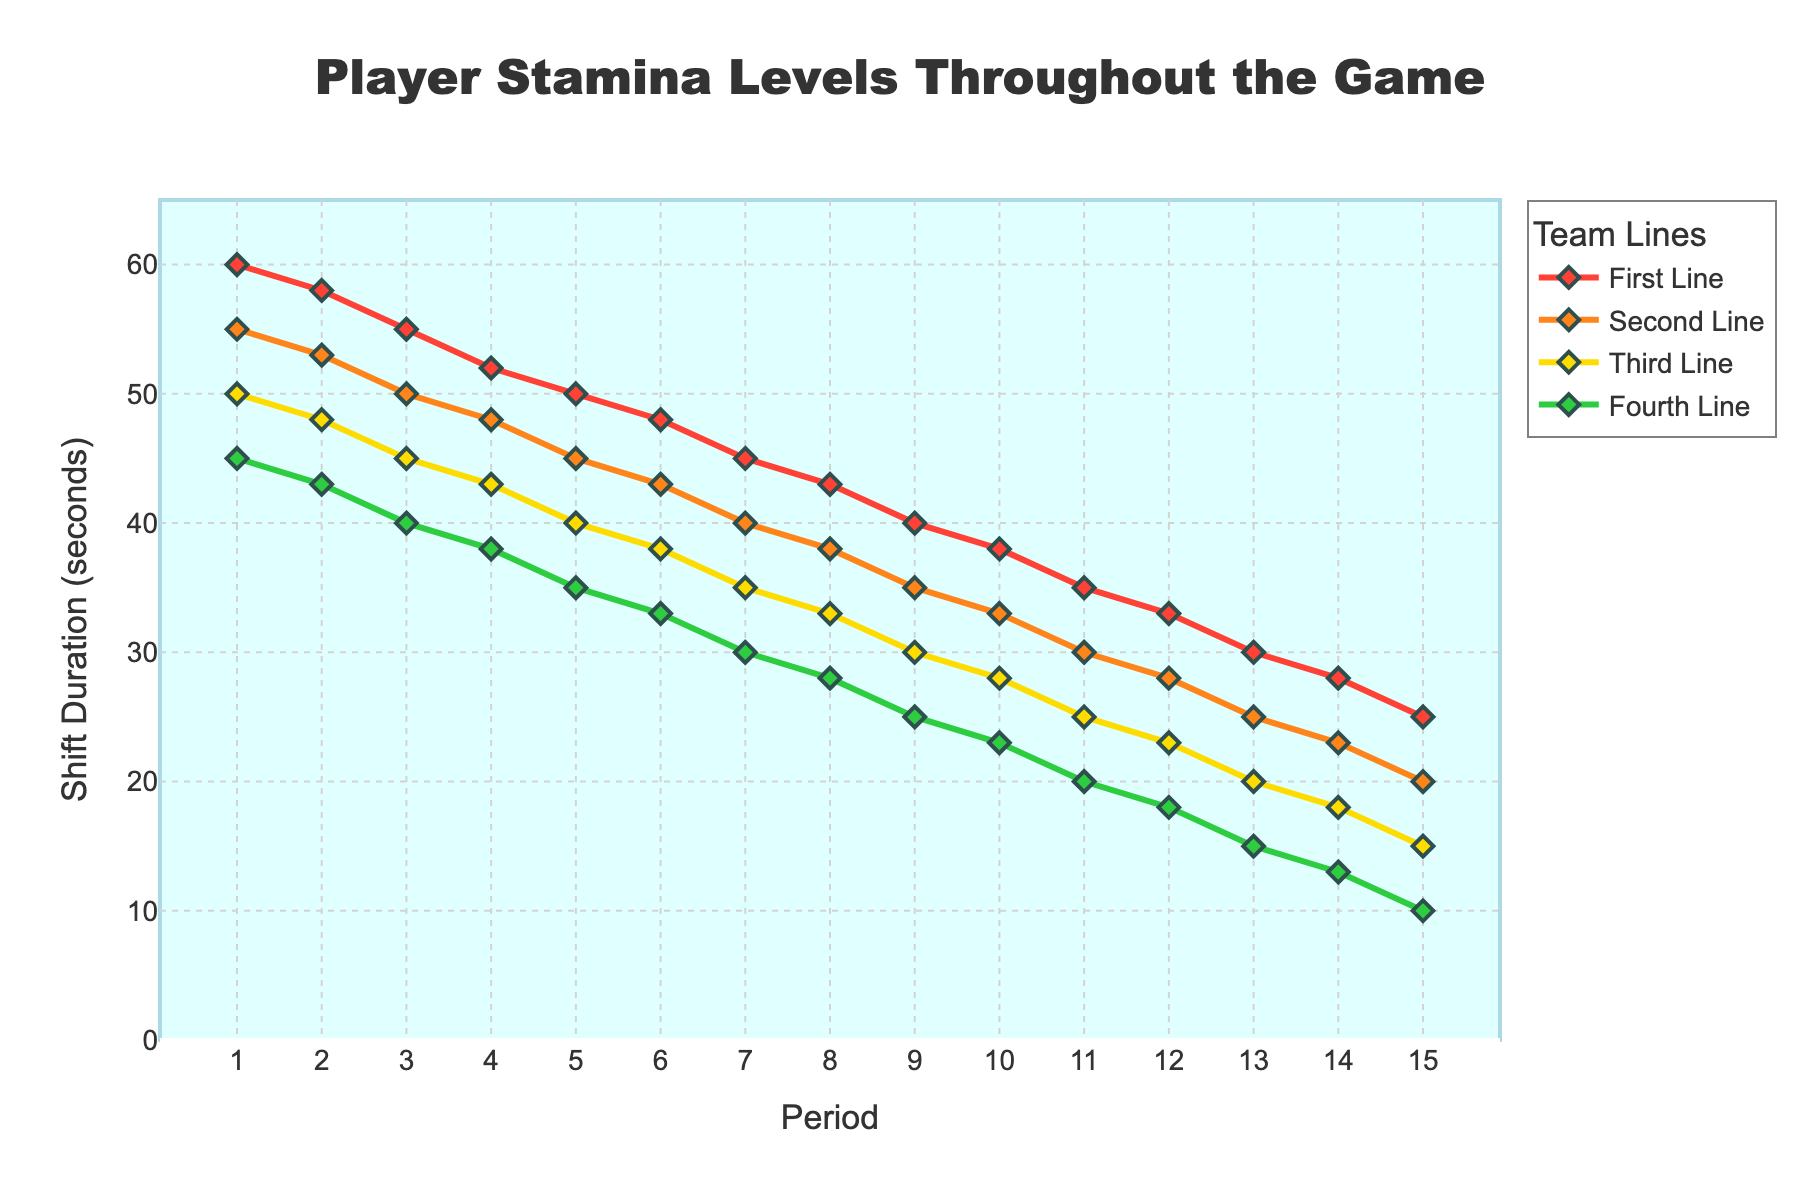Which line shows the greatest drop in shift duration from Period 1 to Period 15? The greatest drop in shift duration is determined by the difference between the shift duration in Period 1 and Period 15 for each line. For the First Line, the drop is 60 - 25 = 35 seconds. For the Second Line, it's 55 - 20 = 35 seconds. For the Third Line, it's 50 - 15 = 35 seconds. For the Fourth Line, it's 45 - 10 = 35 seconds. Therefore, all lines show the same drop of 35 seconds.
Answer: All lines Which line has the highest average shift duration throughout the game? Calculate the average of the shift duration values for each line by summing all shift durations and dividing by the total number of periods (15). The average for the First Line is (60 + 58 + 55 + 52 + 50 + 48 + 45 + 43 + 40 + 38 + 35 + 33 + 30 + 28 + 25)/15 = 43.67 seconds. The Second Line has (55 + 53 + 50 + 48 + 45 + 43 + 40 + 38 + 35 + 33 + 30 + 28 + 25 + 23 + 20)/15 = 39.33 seconds. The Third Line has (50 + 48 + 45 + 43 + 40 + 38 + 35 + 33 + 30 + 28 + 25 + 23 + 20 + 18 + 15)/15 = 34.67 seconds. The Fourth Line has (45 + 43 + 40 + 38 + 35 + 33 + 30 + 28 + 25 + 23 + 20 + 18 + 15 + 13 + 10)/15 = 30.33 seconds. Thus, the First Line has the highest average.
Answer: First Line Which period shows the smallest difference in shift durations between the First Line and Fourth Line? We calculate the difference for each period by subtracting the shift duration of the Fourth Line from the First Line. The differences are: 
Period 1: 60 - 45 = 15 
Period 2: 58 - 43 = 15 
Period 3: 55 - 40 = 15 
Period 4: 52 - 38 = 14 
Period 5: 50 - 35 = 15 
Period 6: 48 - 33 = 15 
Period 7: 45 - 30 = 15 
Period 8: 43 - 28 = 15 
Period 9: 40 - 25 = 15 
Period 10: 38 - 23 = 15 
Period 11: 35 - 20 = 15 
Period 12: 33 - 18 = 15 
Period 13: 30 - 15 = 15 
Period 14: 28 - 13 = 15 
Period 15: 25 - 10 = 15 
The smallest difference is in Period 4 with a difference of 14 seconds.
Answer: Period 4 During which periods do all lines have a shift duration greater than 30 seconds? Review each period and check if all shift durations for the First, Second, Third, and Fourth Lines are above 30 seconds. The periods when all lines meet this criterion are: 
Period 1: All > 30 
Period 2: All > 30 
Period 3: All > 30 
Period 4: All > 30 
Period 5: All > 30 
Period 6: All > 30 
Therefore, the periods are 1 to 6.
Answer: 1 to 6 Which line consistently shows the shortest shift duration throughout the game? Assess the shift durations for each line across all periods. The Fourth Line has the lowest values consistently compared to other lines.
Answer: Fourth Line 